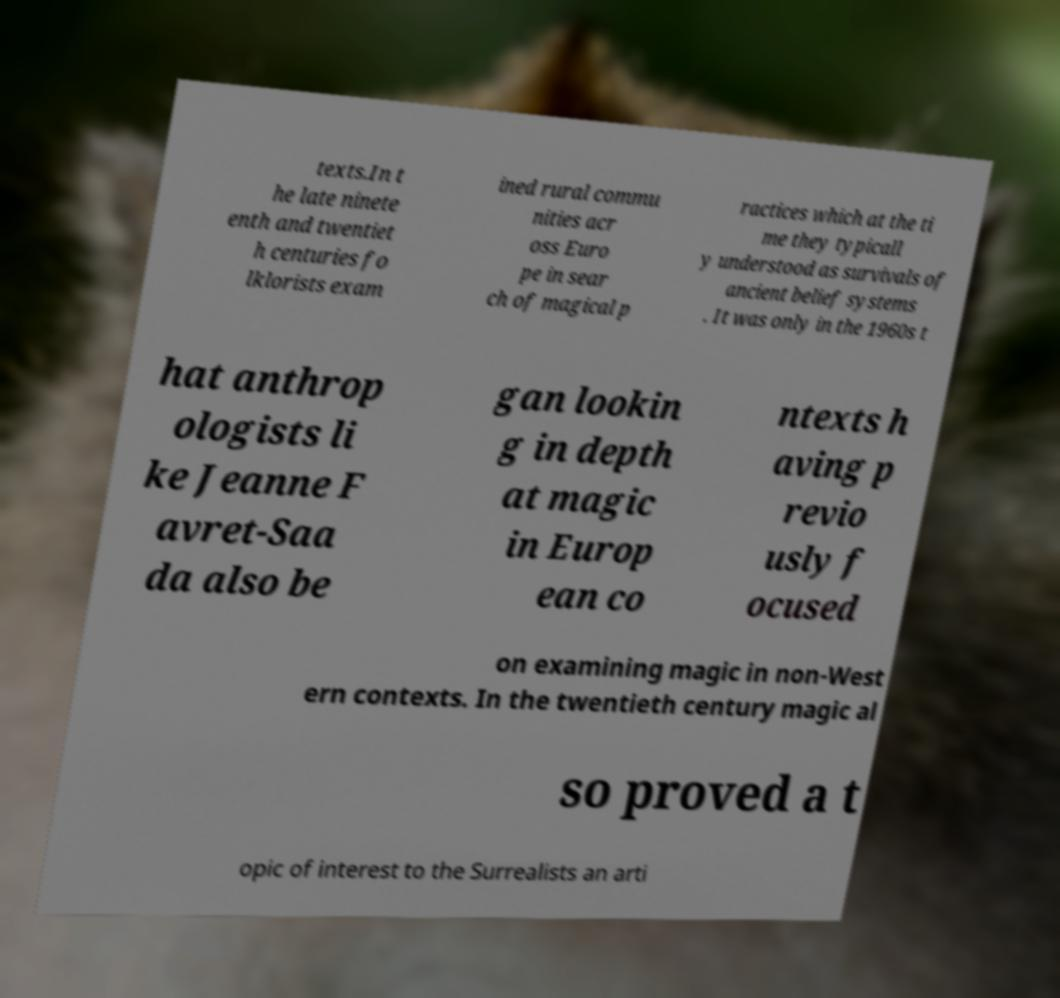Please identify and transcribe the text found in this image. texts.In t he late ninete enth and twentiet h centuries fo lklorists exam ined rural commu nities acr oss Euro pe in sear ch of magical p ractices which at the ti me they typicall y understood as survivals of ancient belief systems . It was only in the 1960s t hat anthrop ologists li ke Jeanne F avret-Saa da also be gan lookin g in depth at magic in Europ ean co ntexts h aving p revio usly f ocused on examining magic in non-West ern contexts. In the twentieth century magic al so proved a t opic of interest to the Surrealists an arti 